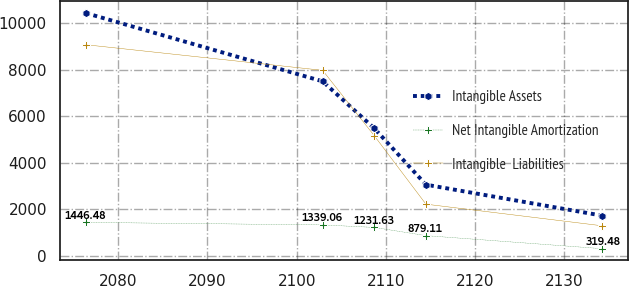Convert chart. <chart><loc_0><loc_0><loc_500><loc_500><line_chart><ecel><fcel>Intangible Assets<fcel>Net Intangible Amortization<fcel>Intangible  Liabilities<nl><fcel>2076.39<fcel>10421.6<fcel>1446.48<fcel>9064.51<nl><fcel>2102.91<fcel>7495.5<fcel>1339.06<fcel>7967.03<nl><fcel>2108.7<fcel>5481.06<fcel>1231.63<fcel>5164.48<nl><fcel>2114.49<fcel>3064.38<fcel>879.11<fcel>2228.88<nl><fcel>2134.25<fcel>1736.61<fcel>319.48<fcel>1300.41<nl></chart> 